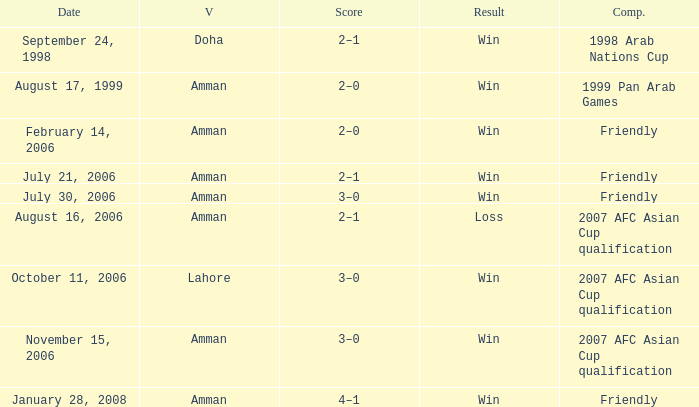Which competition took place on October 11, 2006? 2007 AFC Asian Cup qualification. 